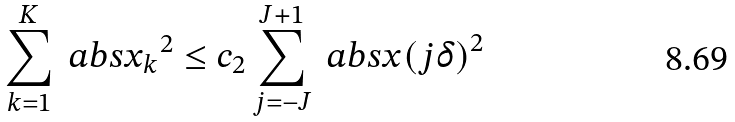<formula> <loc_0><loc_0><loc_500><loc_500>\sum _ { k = 1 } ^ { K } \ a b s { x _ { k } } ^ { 2 } \leq c _ { 2 } \sum _ { j = - J } ^ { J + 1 } \ a b s { x ( j \delta ) } ^ { 2 }</formula> 